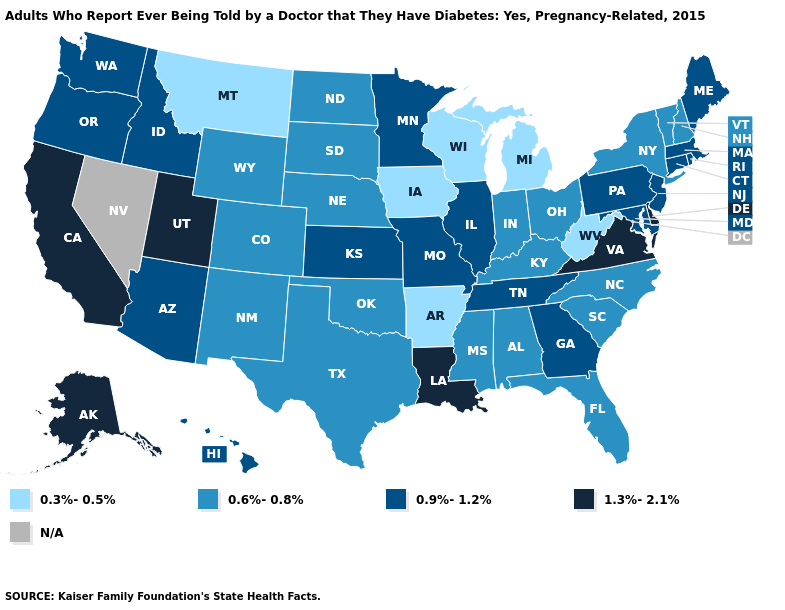Which states have the lowest value in the USA?
Concise answer only. Arkansas, Iowa, Michigan, Montana, West Virginia, Wisconsin. What is the value of Oregon?
Be succinct. 0.9%-1.2%. Name the states that have a value in the range 0.9%-1.2%?
Short answer required. Arizona, Connecticut, Georgia, Hawaii, Idaho, Illinois, Kansas, Maine, Maryland, Massachusetts, Minnesota, Missouri, New Jersey, Oregon, Pennsylvania, Rhode Island, Tennessee, Washington. Name the states that have a value in the range 0.9%-1.2%?
Answer briefly. Arizona, Connecticut, Georgia, Hawaii, Idaho, Illinois, Kansas, Maine, Maryland, Massachusetts, Minnesota, Missouri, New Jersey, Oregon, Pennsylvania, Rhode Island, Tennessee, Washington. What is the value of Virginia?
Answer briefly. 1.3%-2.1%. Name the states that have a value in the range 1.3%-2.1%?
Concise answer only. Alaska, California, Delaware, Louisiana, Utah, Virginia. Name the states that have a value in the range 1.3%-2.1%?
Give a very brief answer. Alaska, California, Delaware, Louisiana, Utah, Virginia. How many symbols are there in the legend?
Answer briefly. 5. Does Delaware have the highest value in the USA?
Answer briefly. Yes. Name the states that have a value in the range 0.9%-1.2%?
Be succinct. Arizona, Connecticut, Georgia, Hawaii, Idaho, Illinois, Kansas, Maine, Maryland, Massachusetts, Minnesota, Missouri, New Jersey, Oregon, Pennsylvania, Rhode Island, Tennessee, Washington. Name the states that have a value in the range 1.3%-2.1%?
Short answer required. Alaska, California, Delaware, Louisiana, Utah, Virginia. Does the first symbol in the legend represent the smallest category?
Concise answer only. Yes. How many symbols are there in the legend?
Short answer required. 5. Name the states that have a value in the range 0.3%-0.5%?
Answer briefly. Arkansas, Iowa, Michigan, Montana, West Virginia, Wisconsin. 